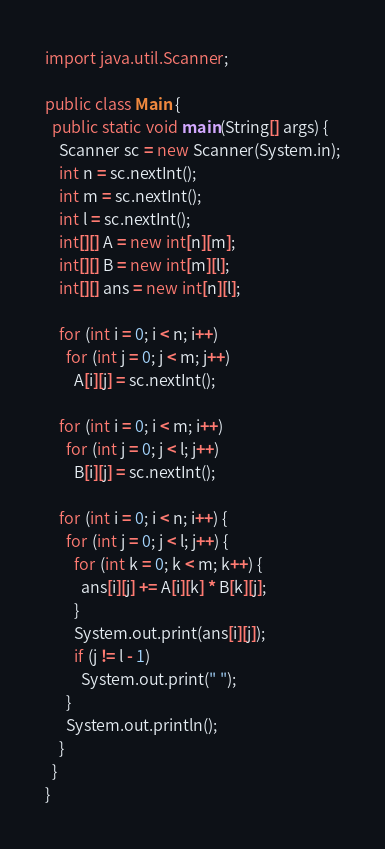<code> <loc_0><loc_0><loc_500><loc_500><_Java_>import java.util.Scanner;

public class Main {
  public static void main(String[] args) {
    Scanner sc = new Scanner(System.in);
    int n = sc.nextInt();
    int m = sc.nextInt();
    int l = sc.nextInt();
    int[][] A = new int[n][m];
    int[][] B = new int[m][l];
    int[][] ans = new int[n][l];

    for (int i = 0; i < n; i++)
      for (int j = 0; j < m; j++)
        A[i][j] = sc.nextInt();

    for (int i = 0; i < m; i++)
      for (int j = 0; j < l; j++)
        B[i][j] = sc.nextInt();

    for (int i = 0; i < n; i++) {
      for (int j = 0; j < l; j++) {
        for (int k = 0; k < m; k++) {
          ans[i][j] += A[i][k] * B[k][j];
        }
        System.out.print(ans[i][j]);
        if (j != l - 1)
          System.out.print(" ");
      }
      System.out.println();
    }
  }
}</code> 